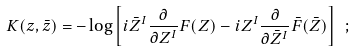<formula> <loc_0><loc_0><loc_500><loc_500>K ( z , \bar { z } ) = - \log \left [ i \bar { Z } ^ { I } \frac { \partial } { \partial Z ^ { I } } F ( Z ) - i Z ^ { I } \frac { \partial } { \partial \bar { Z } ^ { I } } \bar { F } ( \bar { Z } ) \right ] \ ;</formula> 